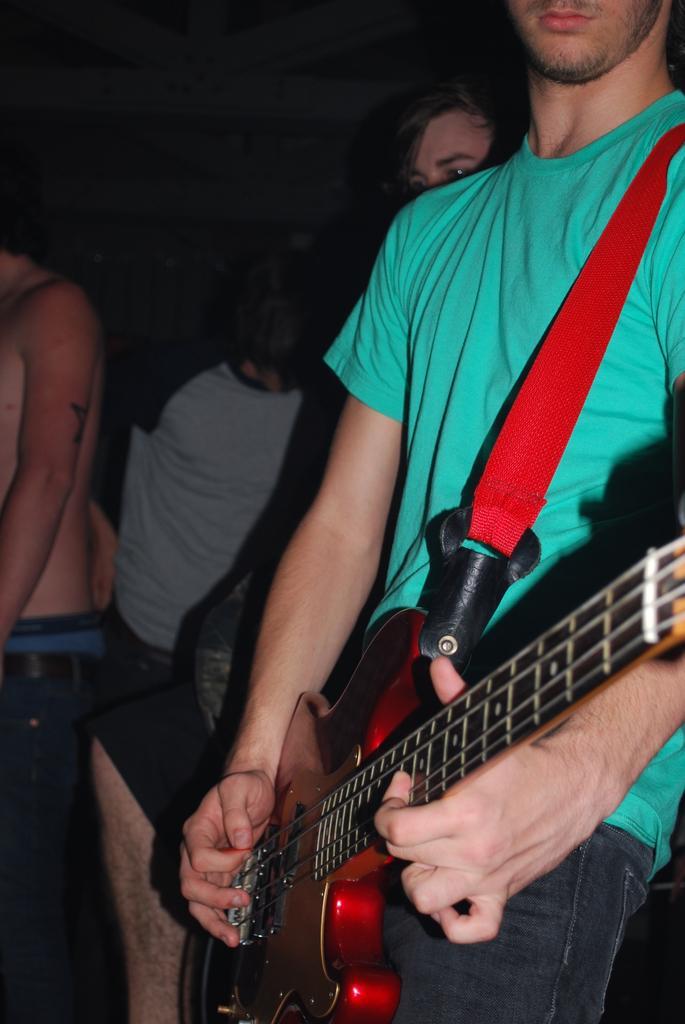Describe this image in one or two sentences. This persons are standing. Front this person is holding a guitar. 